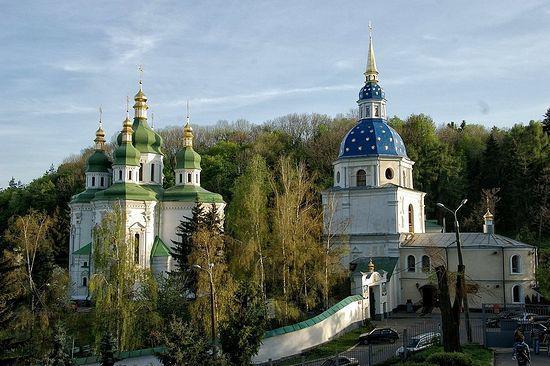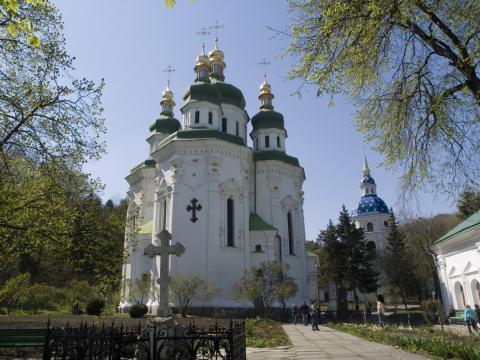The first image is the image on the left, the second image is the image on the right. Considering the images on both sides, is "There are four visible walkways in front of four traditional buildings." valid? Answer yes or no. No. The first image is the image on the left, the second image is the image on the right. Considering the images on both sides, is "At least one image shows a sprawling building that includes a dark blue-gray cone roof on a cylindrical tower." valid? Answer yes or no. No. 